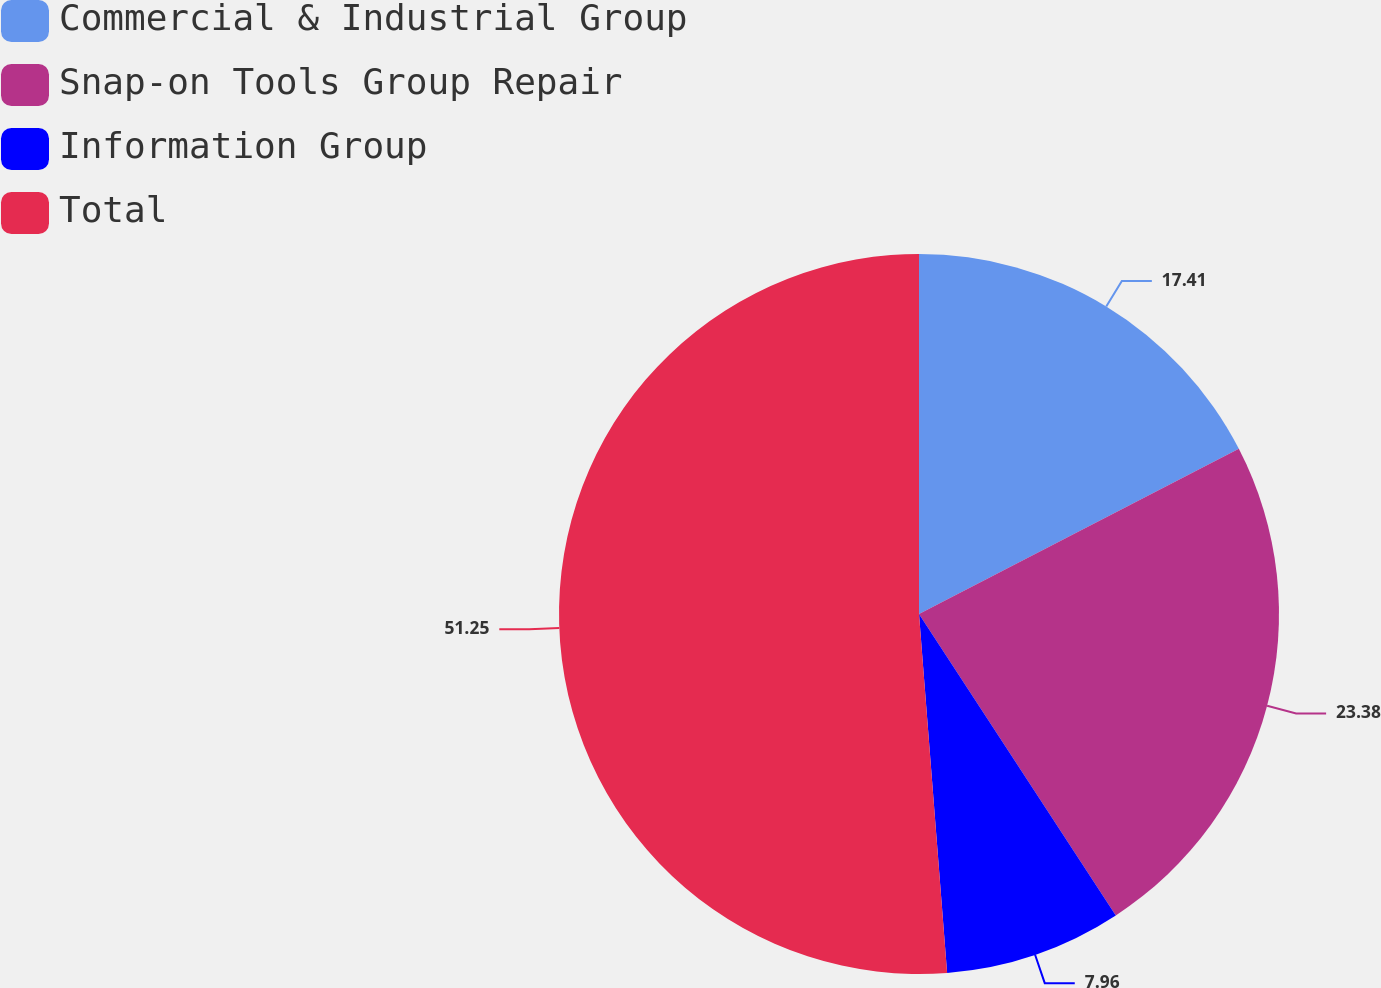Convert chart. <chart><loc_0><loc_0><loc_500><loc_500><pie_chart><fcel>Commercial & Industrial Group<fcel>Snap-on Tools Group Repair<fcel>Information Group<fcel>Total<nl><fcel>17.41%<fcel>23.38%<fcel>7.96%<fcel>51.24%<nl></chart> 